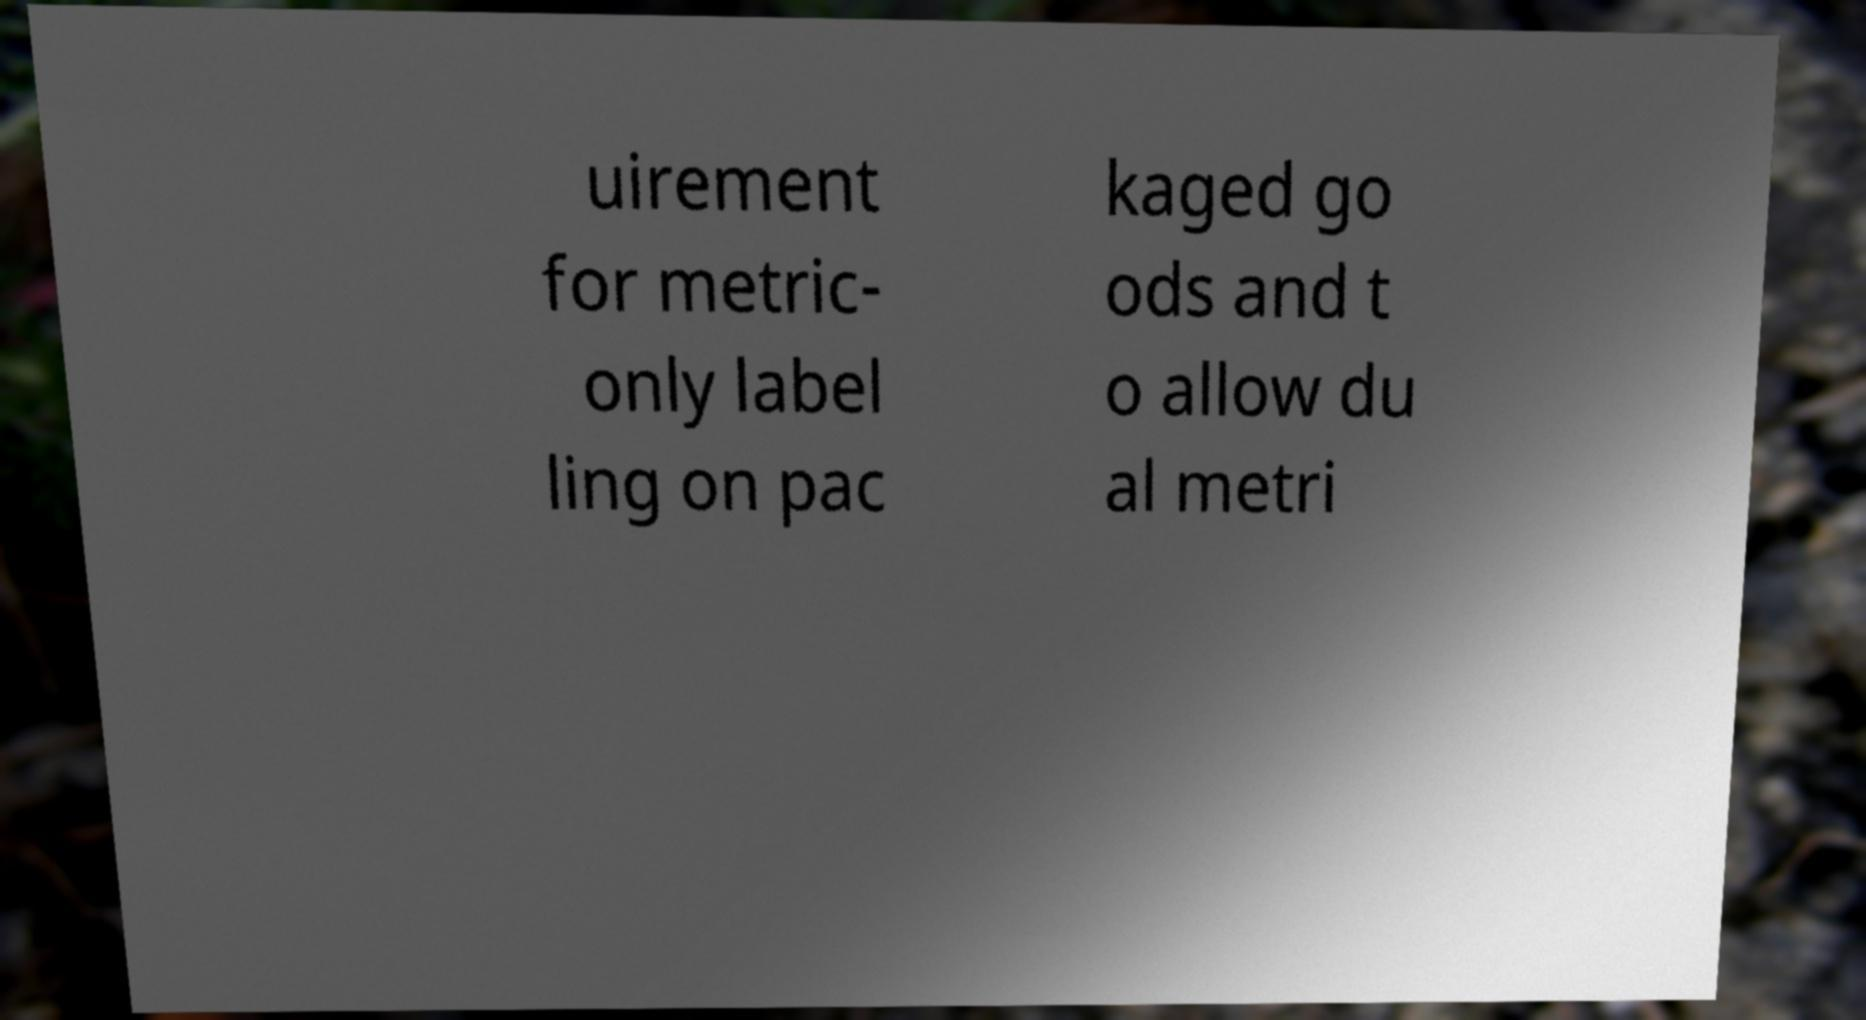Can you read and provide the text displayed in the image?This photo seems to have some interesting text. Can you extract and type it out for me? uirement for metric- only label ling on pac kaged go ods and t o allow du al metri 